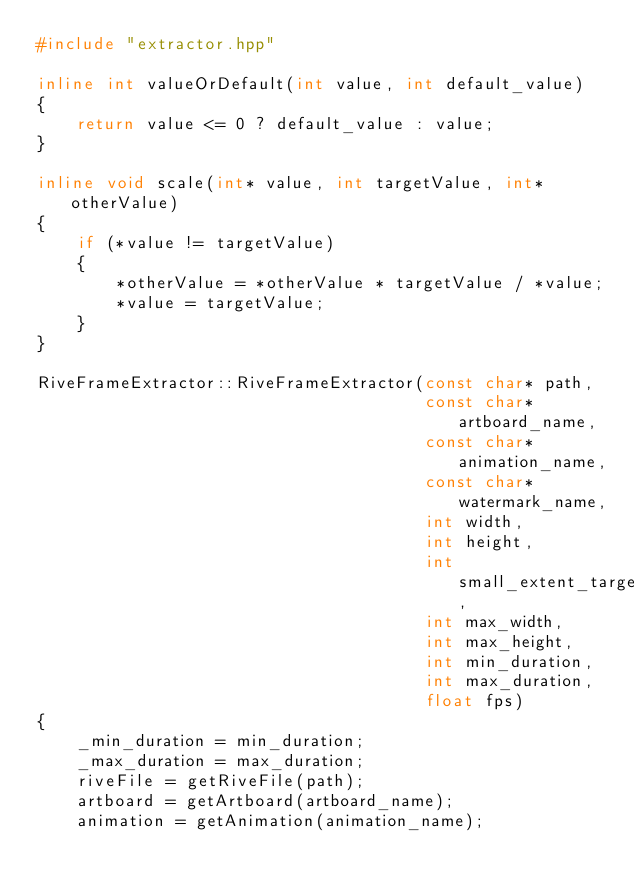Convert code to text. <code><loc_0><loc_0><loc_500><loc_500><_C++_>#include "extractor.hpp"

inline int valueOrDefault(int value, int default_value)
{
	return value <= 0 ? default_value : value;
}

inline void scale(int* value, int targetValue, int* otherValue)
{
	if (*value != targetValue)
	{
		*otherValue = *otherValue * targetValue / *value;
		*value = targetValue;
	}
}

RiveFrameExtractor::RiveFrameExtractor(const char* path,
                                       const char* artboard_name,
                                       const char* animation_name,
                                       const char* watermark_name,
                                       int width,
                                       int height,
                                       int small_extent_target,
                                       int max_width,
                                       int max_height,
                                       int min_duration,
                                       int max_duration,
                                       float fps)
{
	_min_duration = min_duration;
	_max_duration = max_duration;
	riveFile = getRiveFile(path);
	artboard = getArtboard(artboard_name);
	animation = getAnimation(animation_name);</code> 